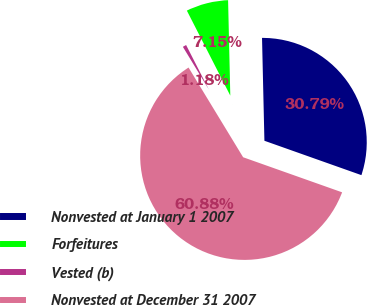Convert chart. <chart><loc_0><loc_0><loc_500><loc_500><pie_chart><fcel>Nonvested at January 1 2007<fcel>Forfeitures<fcel>Vested (b)<fcel>Nonvested at December 31 2007<nl><fcel>30.79%<fcel>7.15%<fcel>1.18%<fcel>60.88%<nl></chart> 